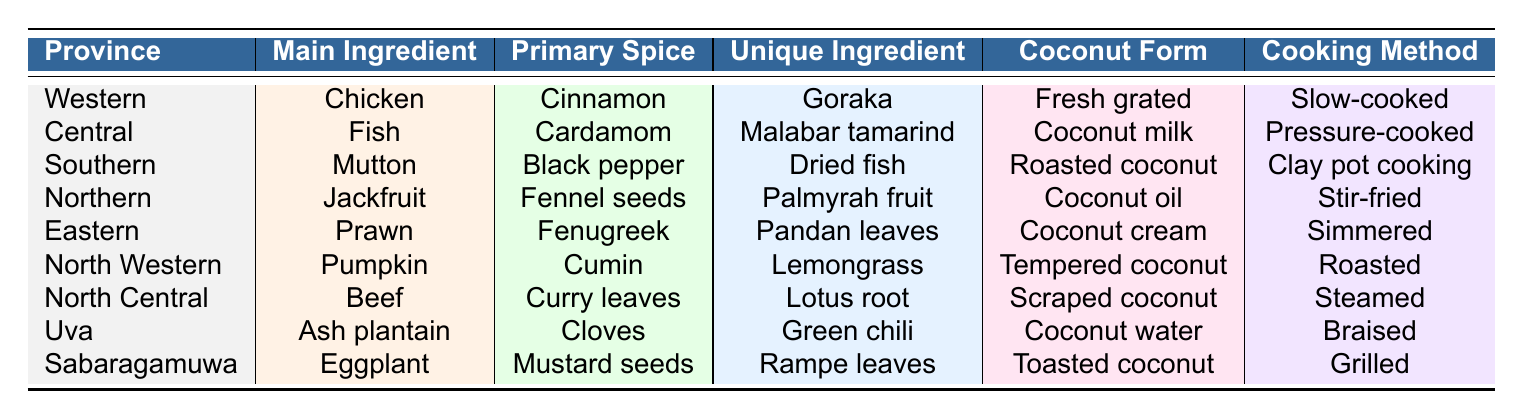What is the main ingredient used in the Northern province? According to the table, the main ingredient listed for the Northern province is Jackfruit.
Answer: Jackfruit Which province uses Coconut cream as the form of coconut? The Eastern province is the one where Coconut cream is used as the form of coconut, as evidenced by the corresponding entry in the table.
Answer: Eastern What unique ingredient is used in the Central province? The unique ingredient for the Central province is Malabar tamarind, as shown in the table.
Answer: Malabar tamarind Is the main ingredient for the Southern province Mutton? Yes, the table confirms that Mutton is the main ingredient for the Southern province.
Answer: Yes How many provinces use fish as a main ingredient? The table shows that only one province, Central, uses Fish as a main ingredient. Therefore, the count is one.
Answer: 1 Which spice is primarily associated with the Western province? The primary spice for the Western province is Cinnamon, as indicated in the table.
Answer: Cinnamon In which provinces is Coconut oil used, and what is the main ingredient in that province? The table indicates Coconut oil is used in the Northern province, where the main ingredient is Jackfruit.
Answer: Northern, Jackfruit Which cooking methods are associated with the Southern and North Central provinces? For the Southern province, the cooking method is Clay pot cooking; for the North Central province, it is Steamed.
Answer: Clay pot cooking and Steamed How do the primary spices used in the Western and Eastern provinces differ? The Western province uses Cinnamon, while the Eastern province uses Fenugreek, showing that their primary spices are different.
Answer: They are different Which province has the unique ingredient Rama leaves, and what is its main ingredient? The unique ingredient Rampe leaves is associated with the Sabaragamuwa province, where Eggplant is the main ingredient.
Answer: Sabaragamuwa, Eggplant What is the average number of unique ingredients used across all provinces listed in the table? There are 9 entries in the unique ingredient column, one for each province, giving an average of 1 unique ingredient per province.
Answer: 1 